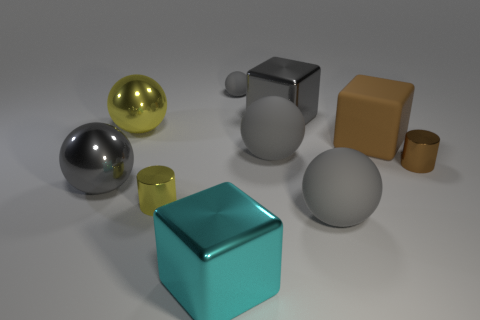How many gray spheres must be subtracted to get 2 gray spheres? 2 Subtract all green cubes. How many gray spheres are left? 4 Subtract 1 spheres. How many spheres are left? 4 Subtract all large yellow metal spheres. How many spheres are left? 4 Subtract all yellow spheres. How many spheres are left? 4 Subtract all gray balls. Subtract all red cylinders. How many balls are left? 1 Subtract all blocks. How many objects are left? 7 Subtract 0 blue balls. How many objects are left? 10 Subtract all brown rubber objects. Subtract all metallic cylinders. How many objects are left? 7 Add 3 small balls. How many small balls are left? 4 